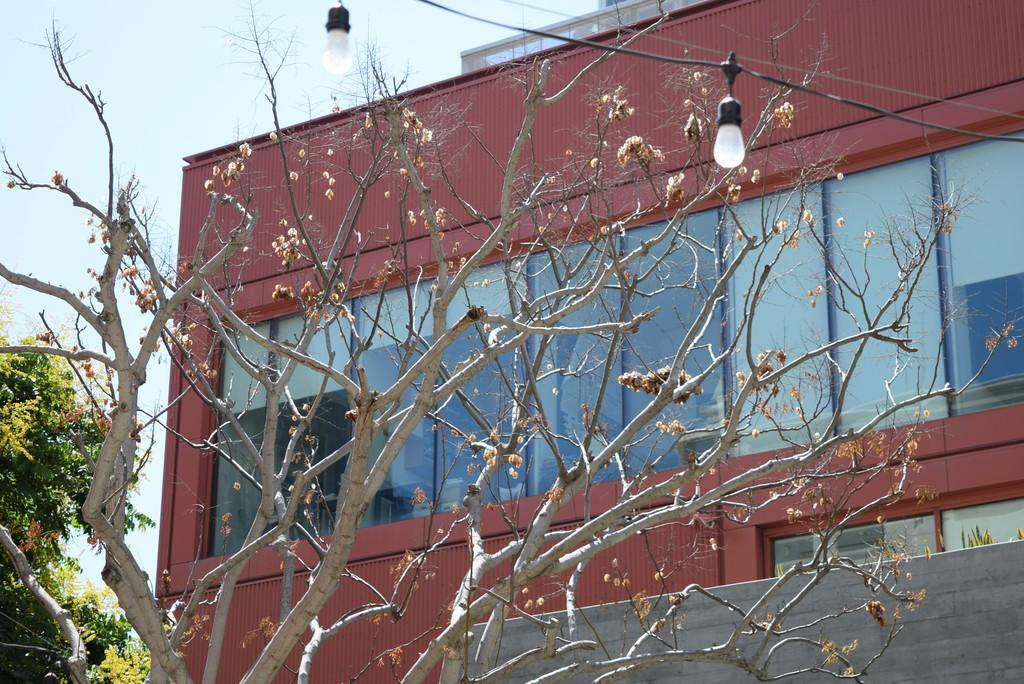What can be seen in the middle of the image? There are trees and flowers in the middle of the image. What is visible in the background of the image? There is a building, trees, a glass window, electric wires, and a bulb in the background of the image. What is the condition of the sky in the image? The sky is visible at the top of the image. What type of suit is hanging on the tree in the image? There is no suit present in the image; it features trees, flowers, and various background elements. What force is being exerted on the flowers in the image? There is no force being exerted on the flowers in the image; they are simply growing and standing in the middle of the image. 